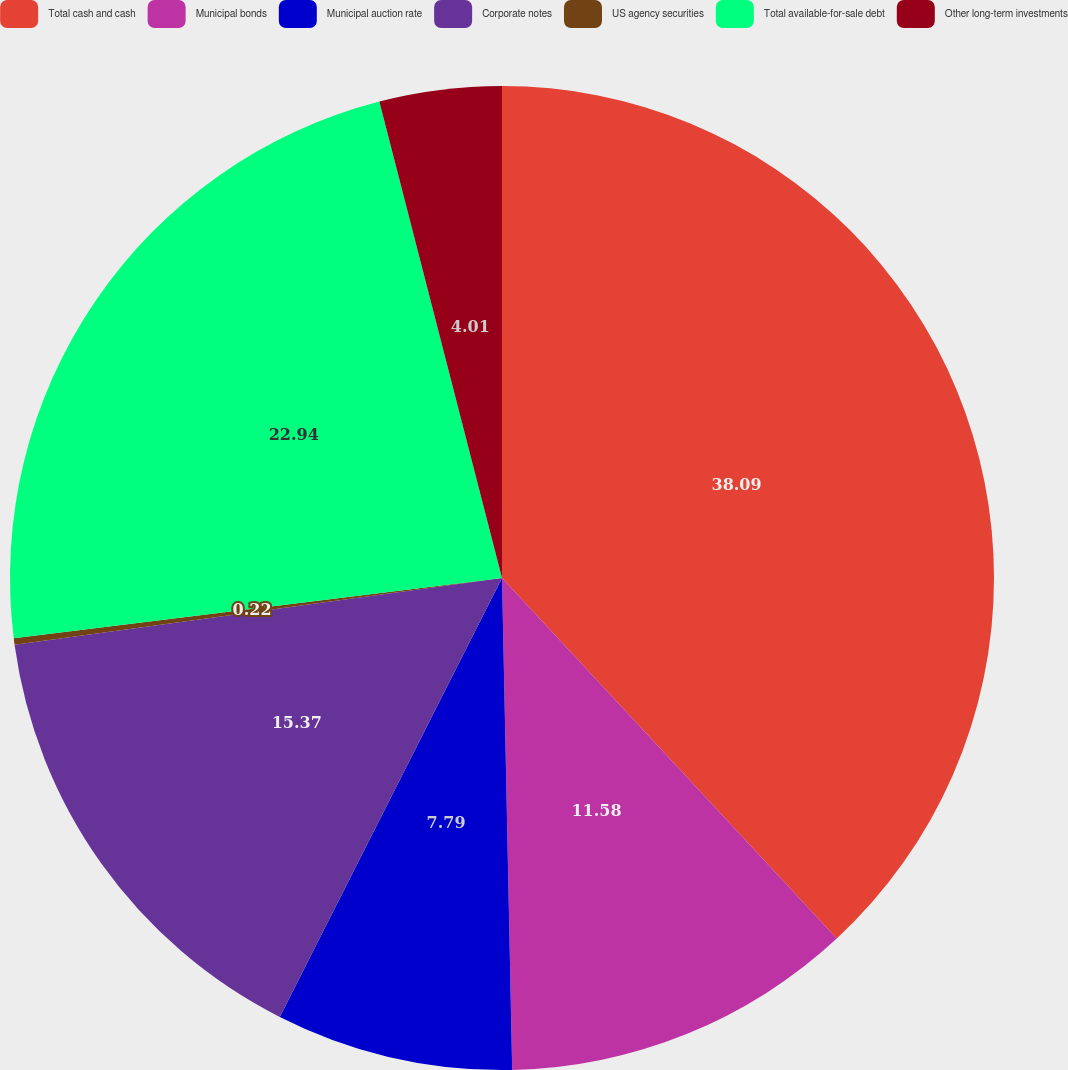Convert chart to OTSL. <chart><loc_0><loc_0><loc_500><loc_500><pie_chart><fcel>Total cash and cash<fcel>Municipal bonds<fcel>Municipal auction rate<fcel>Corporate notes<fcel>US agency securities<fcel>Total available-for-sale debt<fcel>Other long-term investments<nl><fcel>38.09%<fcel>11.58%<fcel>7.79%<fcel>15.37%<fcel>0.22%<fcel>22.94%<fcel>4.01%<nl></chart> 